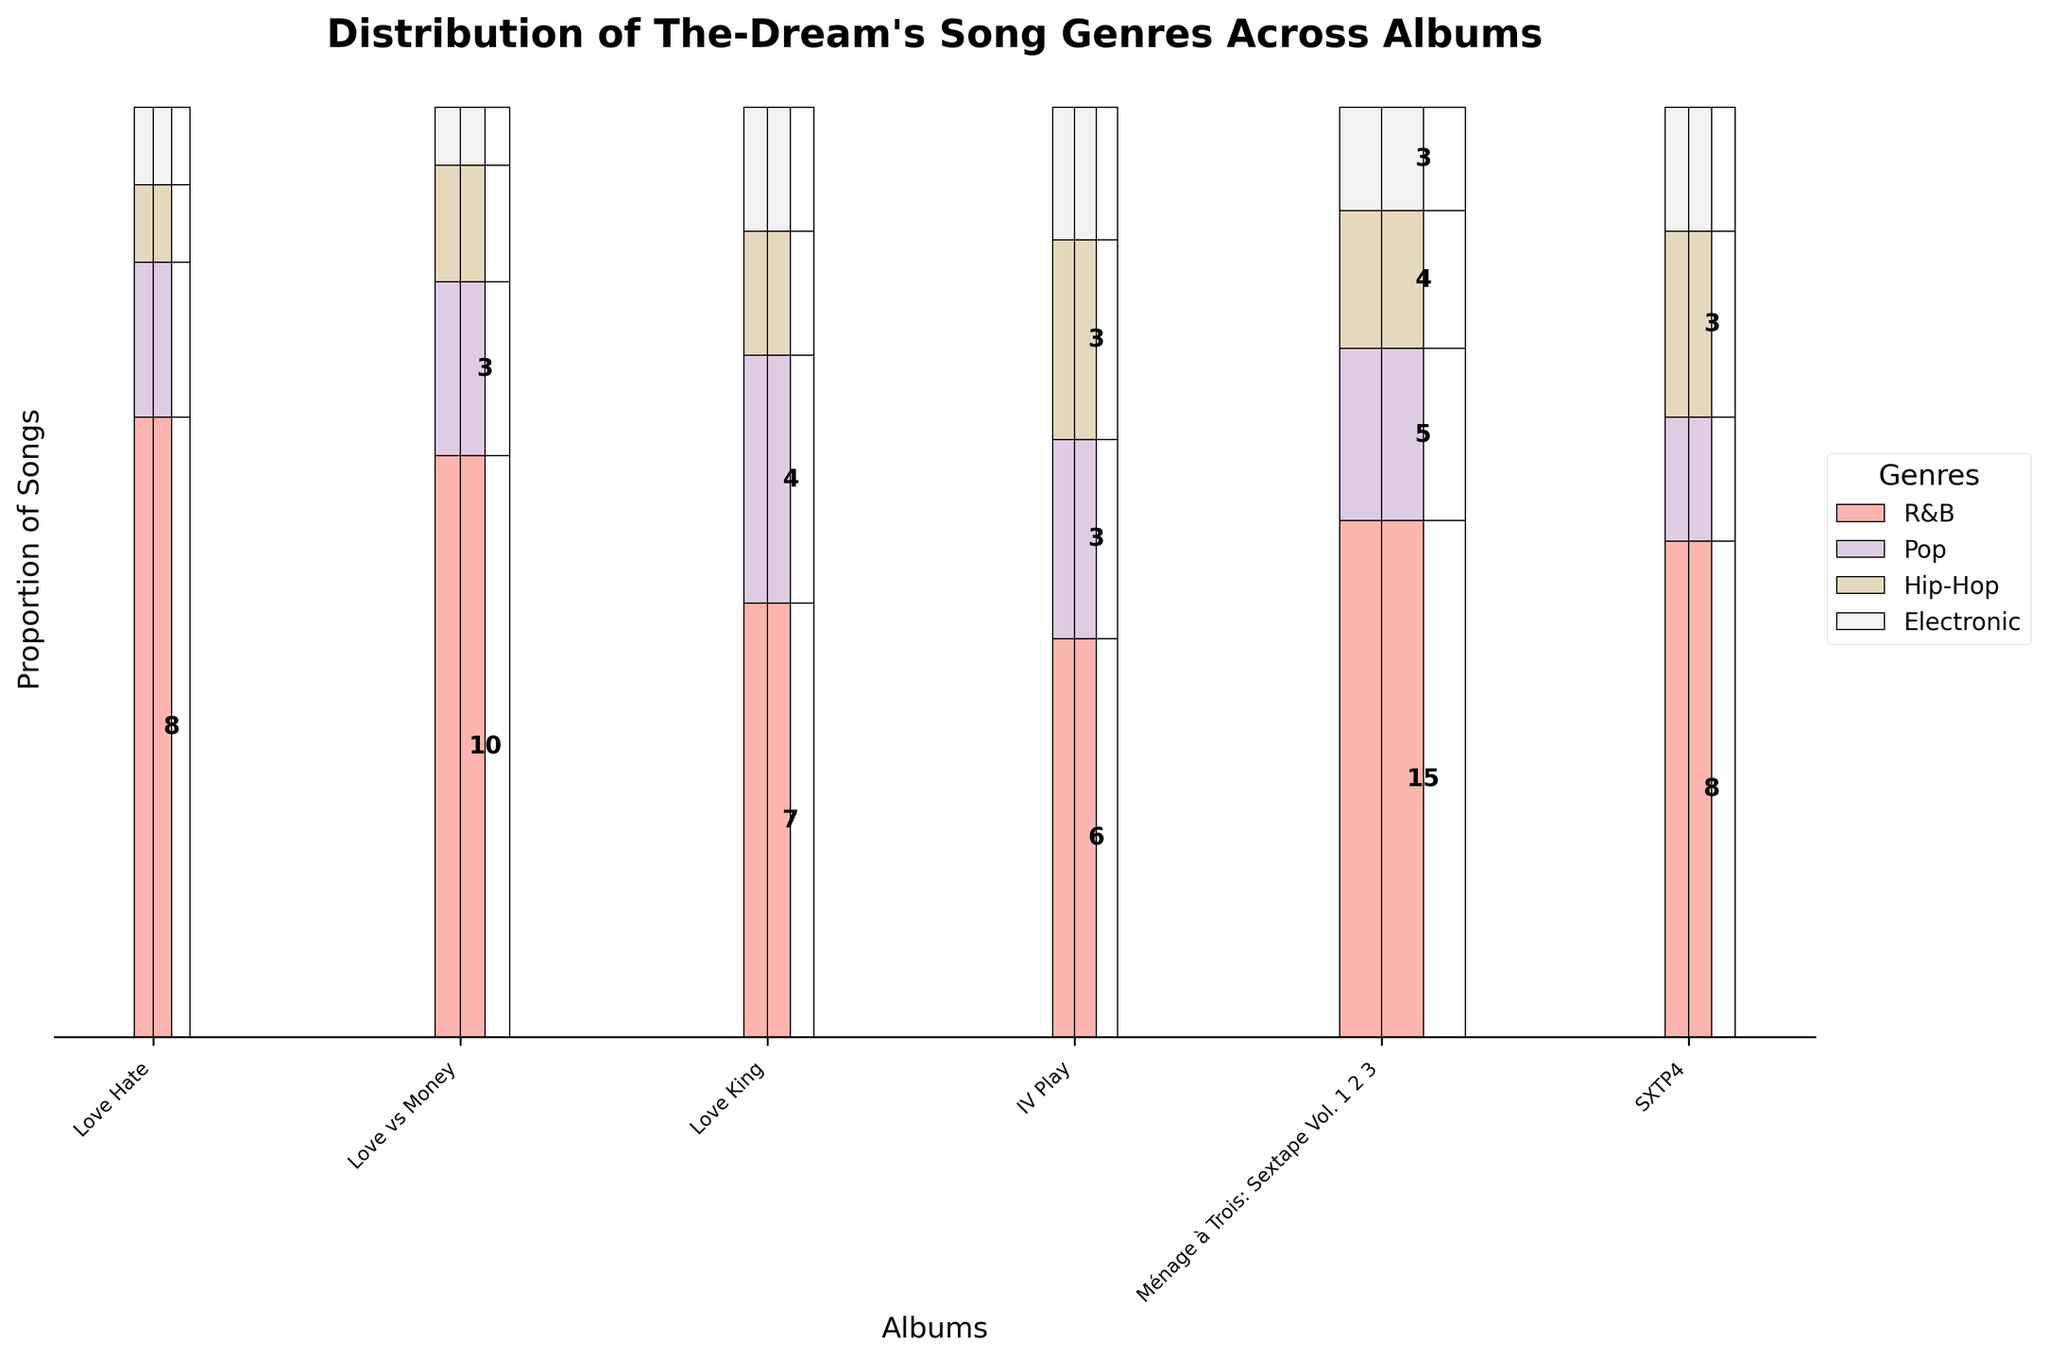What's the most popular genre in the "Love King" album? For "Love King", observe the height of each genre segment. R&B has the tallest segment with 7 songs.
Answer: R&B Which album has the highest number of Pop songs? Compare the height of the Pop segments across all albums. "Ménage à Trois: Sextape Vol. 1 2 3" has the tallest Pop segment with 5 songs.
Answer: Ménage à Trois: Sextape Vol. 1 2 3 How many Electronic songs are in the "IV Play" album? Look at the height of the Electronic segment in the "IV Play" album, which represents 2 songs.
Answer: 2 What is the genre distribution (R&B, Pop, Hip-Hop, Electronic) in the "SXTP4" album? Refer to the heights of each genre in the "SXTP4" album bar: R&B (8 songs), Pop (2 songs), Hip-Hop (3 songs), and Electronic (2 songs).
Answer: R&B: 8, Pop: 2, Hip-Hop: 3, Electronic: 2 Which genre has the least representation in the "Love Hate" album? Observe the segments in "Love Hate" and identify the shortest one: Hip-Hop and Electronic, both with 1 song each.
Answer: Hip-Hop and Electronic Across all albums, which one has the greatest diversity of genres? Compare the number of different genres in each album. "Ménage à Trois: Sextape Vol. 1 2 3" has all four genres with the highest counts.
Answer: Ménage à Trois: Sextape Vol. 1 2 3 Which album features more Hip-Hop songs, "Love vs Money" or "IV Play"? Compare the heights of the Hip-Hop segments between the two albums. "IV Play" has 3 Hip-Hop songs, whereas "Love vs Money" has 2.
Answer: IV Play In which album does the proportion of R&B songs exceed half of the total songs? For each album, check if the height of the R&B segment exceeds the combined height of all other genre segments. "Love vs Money" meets this criterion with 10 out of 16 songs.
Answer: Love vs Money How many albums have at least one Pop song? Go through each album and count those with a Pop segment. There are 6 albums with at least one Pop song.
Answer: 6 